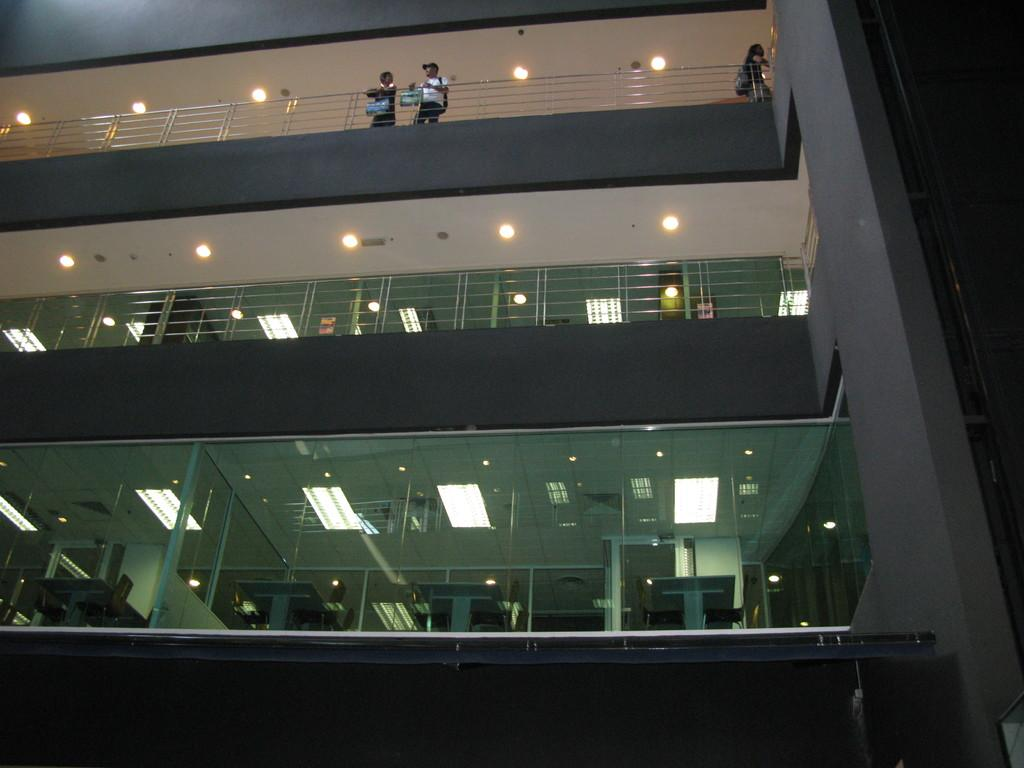What is the main structure in the image? There is a building in the image. What are the people at the top of the building doing? The people are standing at the top of the building. What type of kite is being flown by the building's manager in the image? There is no kite or manager present in the image. 